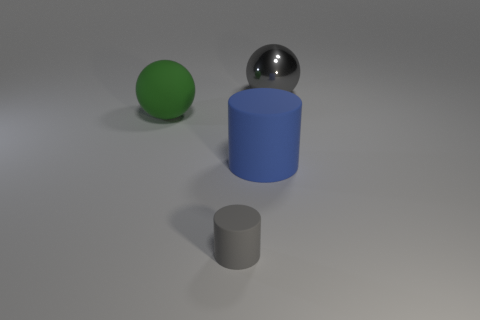What size is the other object that is the same shape as the small gray matte object?
Keep it short and to the point. Large. What number of red things are either tiny rubber blocks or big rubber cylinders?
Offer a very short reply. 0. There is a big sphere that is to the left of the big shiny ball; what number of small gray rubber cylinders are to the right of it?
Your answer should be compact. 1. How many other things are there of the same shape as the gray metal thing?
Ensure brevity in your answer.  1. There is another small thing that is the same color as the shiny thing; what is it made of?
Make the answer very short. Rubber. What number of tiny rubber cylinders are the same color as the large metal thing?
Your response must be concise. 1. There is a sphere that is the same material as the small cylinder; what is its color?
Offer a very short reply. Green. Is there a thing of the same size as the gray cylinder?
Offer a terse response. No. Are there more large blue rubber things that are behind the metallic ball than gray metallic spheres behind the big blue cylinder?
Offer a terse response. No. Are the large sphere to the right of the green object and the big object in front of the green object made of the same material?
Give a very brief answer. No. 